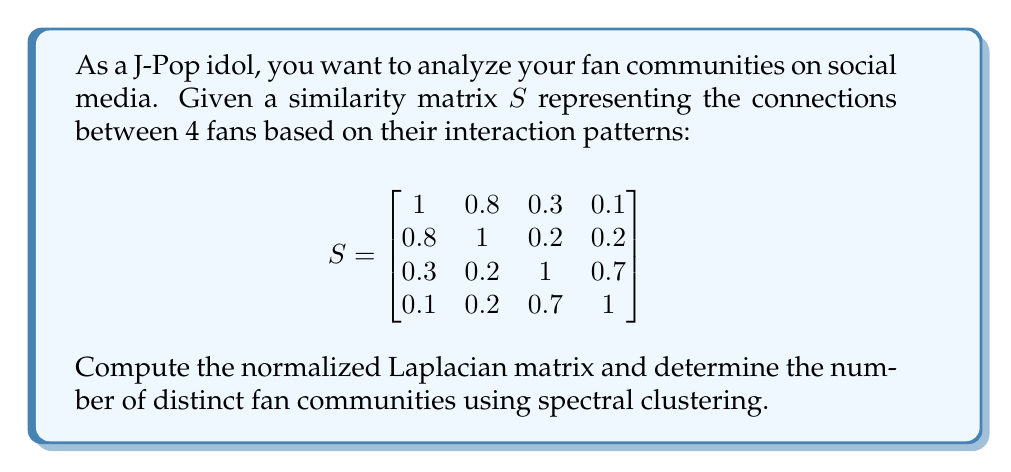Could you help me with this problem? To solve this problem, we'll follow these steps:

1) Compute the degree matrix $D$:
   $$D = \begin{bmatrix}
   2.2 & 0 & 0 & 0 \\
   0 & 2.2 & 0 & 0 \\
   0 & 0 & 2.2 & 0 \\
   0 & 0 & 0 & 2.0
   \end{bmatrix}$$

2) Calculate the normalized Laplacian matrix $L_{sym}$:
   $L_{sym} = I - D^{-1/2}SD^{-1/2}$

   $$L_{sym} = I - \begin{bmatrix}
   0.6742 & 0.5394 & 0.2021 & 0.0674 \\
   0.5394 & 0.6742 & 0.1348 & 0.1348 \\
   0.2021 & 0.1348 & 0.6742 & 0.4719 \\
   0.0674 & 0.1348 & 0.4719 & 0.7071
   \end{bmatrix}$$

   $$L_{sym} = \begin{bmatrix}
   0.3258 & -0.5394 & -0.2021 & -0.0674 \\
   -0.5394 & 0.3258 & -0.1348 & -0.1348 \\
   -0.2021 & -0.1348 & 0.3258 & -0.4719 \\
   -0.0674 & -0.1348 & -0.4719 & 0.2929
   \end{bmatrix}$$

3) Compute the eigenvalues of $L_{sym}$:
   $\lambda_1 = 0$
   $\lambda_2 = 0.0478$
   $\lambda_3 = 0.3227$
   $\lambda_4 = 1.5998$

4) The number of clusters is determined by the number of eigenvalues close to zero. Here, we see a significant gap between $\lambda_2$ and $\lambda_3$, suggesting two distinct clusters.

Therefore, there are 2 distinct fan communities in this social media data.
Answer: 2 distinct fan communities 